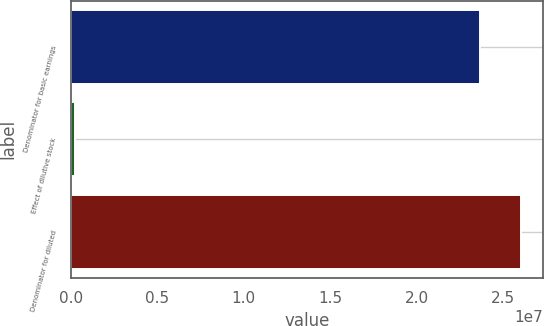Convert chart to OTSL. <chart><loc_0><loc_0><loc_500><loc_500><bar_chart><fcel>Denominator for basic earnings<fcel>Effect of dilutive stock<fcel>Denominator for diluted<nl><fcel>2.36481e+07<fcel>266646<fcel>2.60129e+07<nl></chart> 